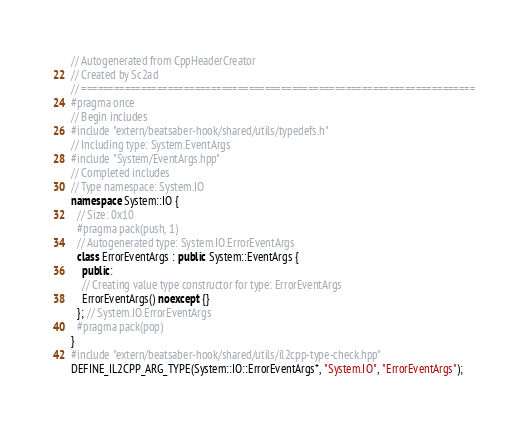<code> <loc_0><loc_0><loc_500><loc_500><_C++_>// Autogenerated from CppHeaderCreator
// Created by Sc2ad
// =========================================================================
#pragma once
// Begin includes
#include "extern/beatsaber-hook/shared/utils/typedefs.h"
// Including type: System.EventArgs
#include "System/EventArgs.hpp"
// Completed includes
// Type namespace: System.IO
namespace System::IO {
  // Size: 0x10
  #pragma pack(push, 1)
  // Autogenerated type: System.IO.ErrorEventArgs
  class ErrorEventArgs : public System::EventArgs {
    public:
    // Creating value type constructor for type: ErrorEventArgs
    ErrorEventArgs() noexcept {}
  }; // System.IO.ErrorEventArgs
  #pragma pack(pop)
}
#include "extern/beatsaber-hook/shared/utils/il2cpp-type-check.hpp"
DEFINE_IL2CPP_ARG_TYPE(System::IO::ErrorEventArgs*, "System.IO", "ErrorEventArgs");
</code> 